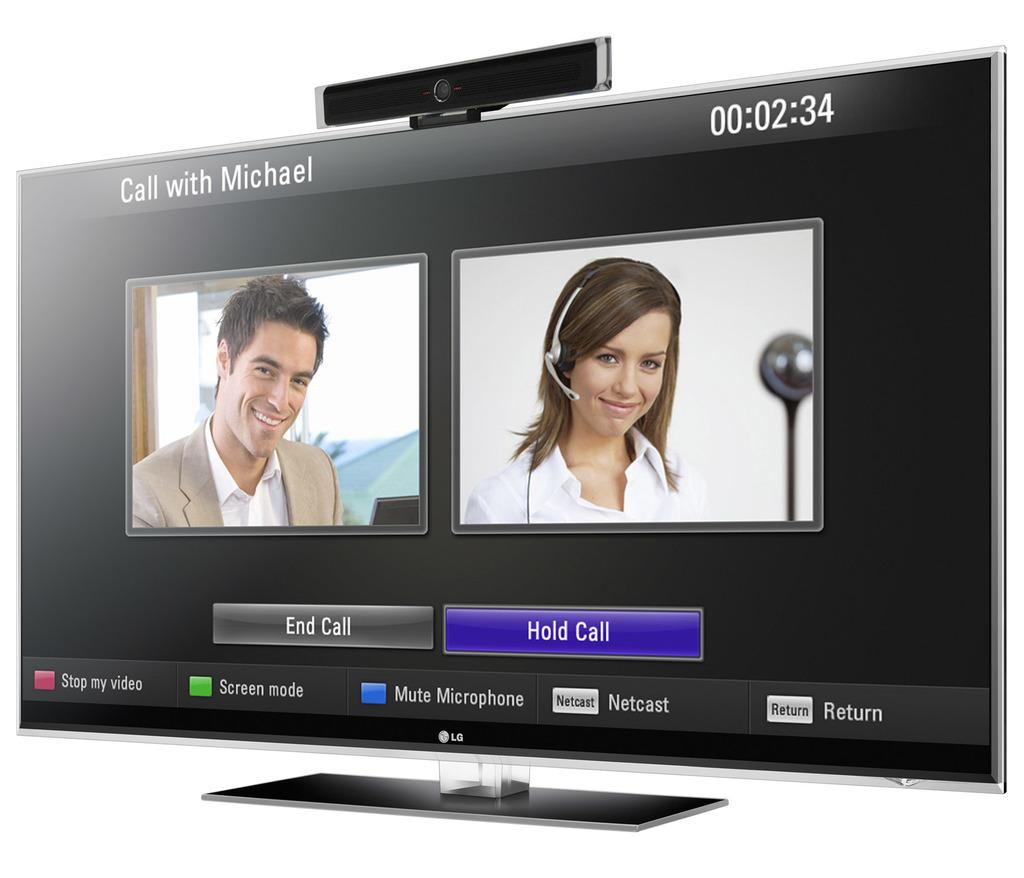What is the man's name?
Your response must be concise. Michael. What is the time?
Your answer should be very brief. 2:34. 